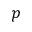Convert formula to latex. <formula><loc_0><loc_0><loc_500><loc_500>p</formula> 